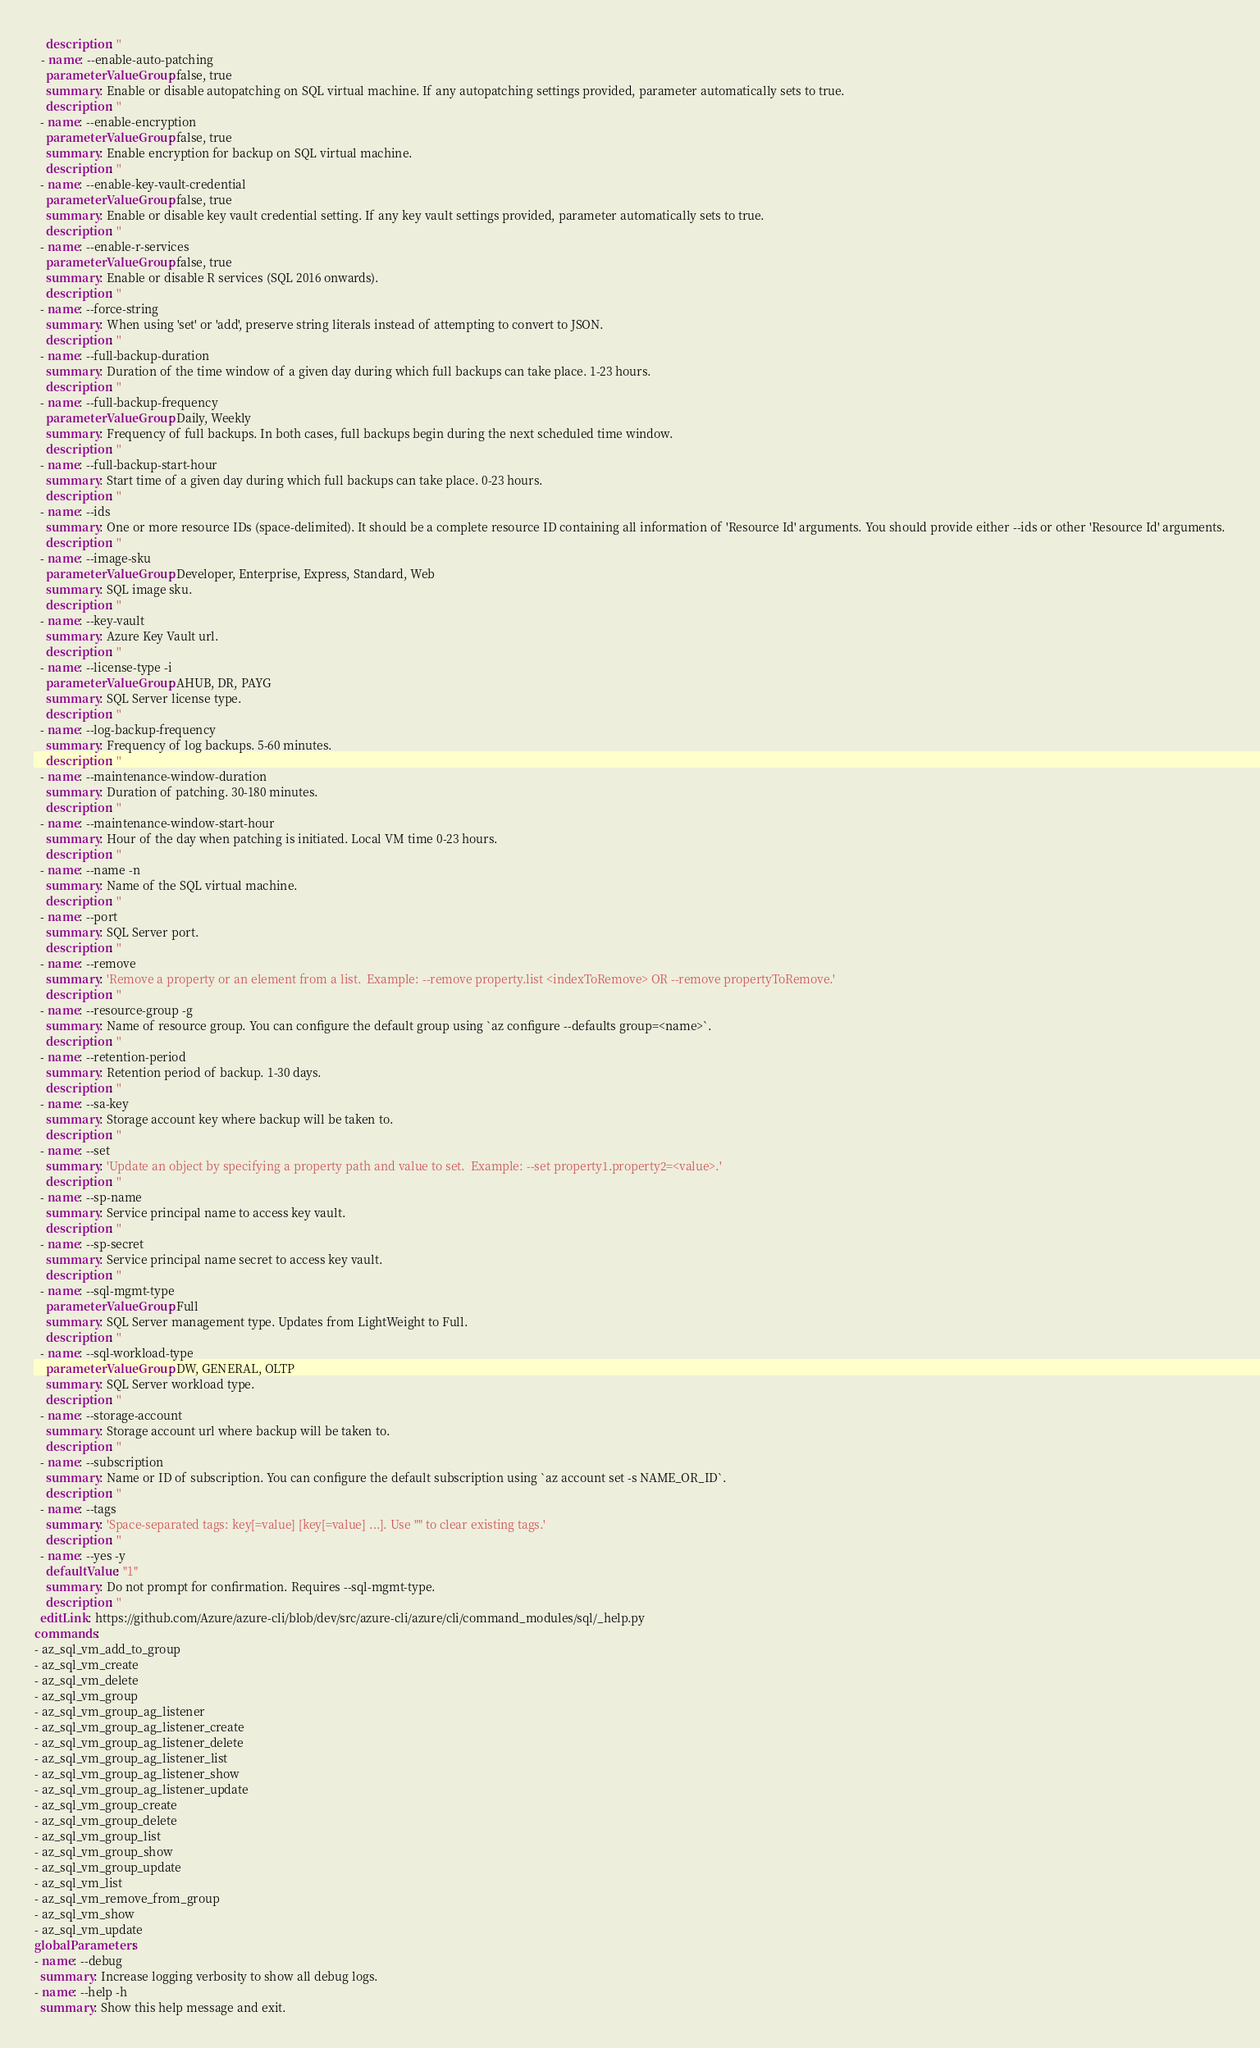Convert code to text. <code><loc_0><loc_0><loc_500><loc_500><_YAML_>    description: ''
  - name: --enable-auto-patching
    parameterValueGroup: false, true
    summary: Enable or disable autopatching on SQL virtual machine. If any autopatching settings provided, parameter automatically sets to true.
    description: ''
  - name: --enable-encryption
    parameterValueGroup: false, true
    summary: Enable encryption for backup on SQL virtual machine.
    description: ''
  - name: --enable-key-vault-credential
    parameterValueGroup: false, true
    summary: Enable or disable key vault credential setting. If any key vault settings provided, parameter automatically sets to true.
    description: ''
  - name: --enable-r-services
    parameterValueGroup: false, true
    summary: Enable or disable R services (SQL 2016 onwards).
    description: ''
  - name: --force-string
    summary: When using 'set' or 'add', preserve string literals instead of attempting to convert to JSON.
    description: ''
  - name: --full-backup-duration
    summary: Duration of the time window of a given day during which full backups can take place. 1-23 hours.
    description: ''
  - name: --full-backup-frequency
    parameterValueGroup: Daily, Weekly
    summary: Frequency of full backups. In both cases, full backups begin during the next scheduled time window.
    description: ''
  - name: --full-backup-start-hour
    summary: Start time of a given day during which full backups can take place. 0-23 hours.
    description: ''
  - name: --ids
    summary: One or more resource IDs (space-delimited). It should be a complete resource ID containing all information of 'Resource Id' arguments. You should provide either --ids or other 'Resource Id' arguments.
    description: ''
  - name: --image-sku
    parameterValueGroup: Developer, Enterprise, Express, Standard, Web
    summary: SQL image sku.
    description: ''
  - name: --key-vault
    summary: Azure Key Vault url.
    description: ''
  - name: --license-type -i
    parameterValueGroup: AHUB, DR, PAYG
    summary: SQL Server license type.
    description: ''
  - name: --log-backup-frequency
    summary: Frequency of log backups. 5-60 minutes.
    description: ''
  - name: --maintenance-window-duration
    summary: Duration of patching. 30-180 minutes.
    description: ''
  - name: --maintenance-window-start-hour
    summary: Hour of the day when patching is initiated. Local VM time 0-23 hours.
    description: ''
  - name: --name -n
    summary: Name of the SQL virtual machine.
    description: ''
  - name: --port
    summary: SQL Server port.
    description: ''
  - name: --remove
    summary: 'Remove a property or an element from a list.  Example: --remove property.list <indexToRemove> OR --remove propertyToRemove.'
    description: ''
  - name: --resource-group -g
    summary: Name of resource group. You can configure the default group using `az configure --defaults group=<name>`.
    description: ''
  - name: --retention-period
    summary: Retention period of backup. 1-30 days.
    description: ''
  - name: --sa-key
    summary: Storage account key where backup will be taken to.
    description: ''
  - name: --set
    summary: 'Update an object by specifying a property path and value to set.  Example: --set property1.property2=<value>.'
    description: ''
  - name: --sp-name
    summary: Service principal name to access key vault.
    description: ''
  - name: --sp-secret
    summary: Service principal name secret to access key vault.
    description: ''
  - name: --sql-mgmt-type
    parameterValueGroup: Full
    summary: SQL Server management type. Updates from LightWeight to Full.
    description: ''
  - name: --sql-workload-type
    parameterValueGroup: DW, GENERAL, OLTP
    summary: SQL Server workload type.
    description: ''
  - name: --storage-account
    summary: Storage account url where backup will be taken to.
    description: ''
  - name: --subscription
    summary: Name or ID of subscription. You can configure the default subscription using `az account set -s NAME_OR_ID`.
    description: ''
  - name: --tags
    summary: 'Space-separated tags: key[=value] [key[=value] ...]. Use "" to clear existing tags.'
    description: ''
  - name: --yes -y
    defaultValue: "1"
    summary: Do not prompt for confirmation. Requires --sql-mgmt-type.
    description: ''
  editLink: https://github.com/Azure/azure-cli/blob/dev/src/azure-cli/azure/cli/command_modules/sql/_help.py
commands:
- az_sql_vm_add_to_group
- az_sql_vm_create
- az_sql_vm_delete
- az_sql_vm_group
- az_sql_vm_group_ag_listener
- az_sql_vm_group_ag_listener_create
- az_sql_vm_group_ag_listener_delete
- az_sql_vm_group_ag_listener_list
- az_sql_vm_group_ag_listener_show
- az_sql_vm_group_ag_listener_update
- az_sql_vm_group_create
- az_sql_vm_group_delete
- az_sql_vm_group_list
- az_sql_vm_group_show
- az_sql_vm_group_update
- az_sql_vm_list
- az_sql_vm_remove_from_group
- az_sql_vm_show
- az_sql_vm_update
globalParameters:
- name: --debug
  summary: Increase logging verbosity to show all debug logs.
- name: --help -h
  summary: Show this help message and exit.</code> 